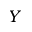Convert formula to latex. <formula><loc_0><loc_0><loc_500><loc_500>Y</formula> 